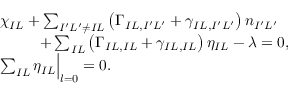Convert formula to latex. <formula><loc_0><loc_0><loc_500><loc_500>\begin{array} { r l } & { \chi _ { I L } + \sum _ { I ^ { \prime } L ^ { \prime } \ne I L } \left ( \Gamma _ { I L , I ^ { \prime } L ^ { \prime } } + \gamma _ { I L , I ^ { \prime } L ^ { \prime } } \right ) n _ { I ^ { \prime } L ^ { \prime } } } \\ & { + \sum _ { I L } \left ( \Gamma _ { I L , I L } + \gamma _ { I L , I L } \right ) \eta _ { I L } - \lambda = 0 , } \\ & { \sum _ { I L } \eta _ { I L } \Big | _ { l = 0 } = 0 . } \end{array}</formula> 